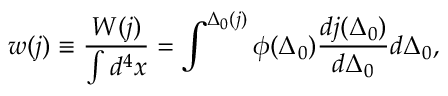<formula> <loc_0><loc_0><loc_500><loc_500>w ( j ) \equiv \frac { W ( j ) } { \int d ^ { 4 } x } = \int ^ { \Delta _ { 0 } ( j ) } \phi ( \Delta _ { 0 } ) \frac { d j ( \Delta _ { 0 } ) } { d \Delta _ { 0 } } d \Delta _ { 0 } ,</formula> 